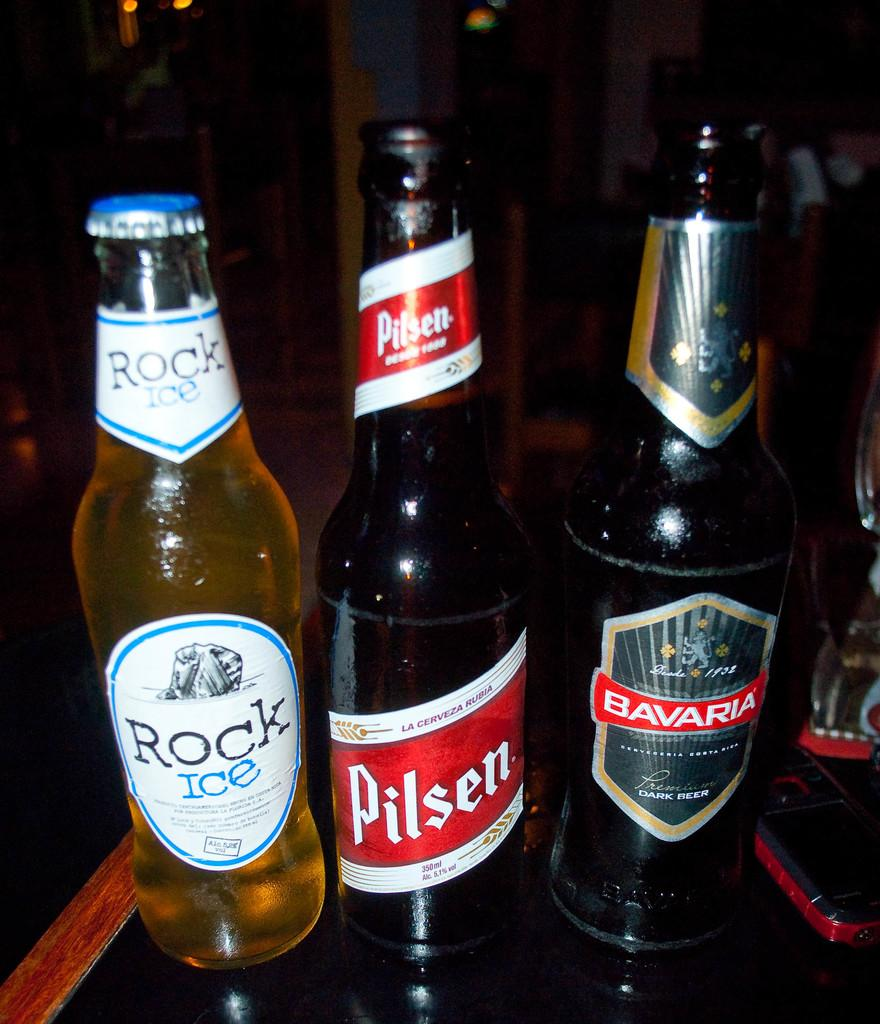<image>
Share a concise interpretation of the image provided. Three bottles sit in a line, the lightest is a Rock Ice, while the Pilsen and Bavaria are darker. 